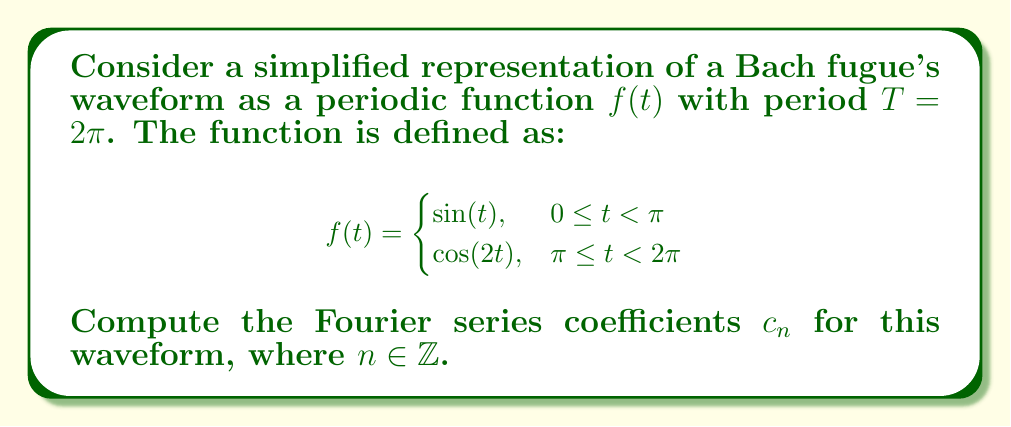Can you solve this math problem? To find the Fourier series coefficients $c_n$, we use the formula:

$$c_n = \frac{1}{T} \int_0^T f(t) e^{-i n t} dt$$

Where $T = 2\pi$ in this case. We split the integral into two parts:

$$c_n = \frac{1}{2\pi} \left( \int_0^\pi \sin(t) e^{-int} dt + \int_\pi^{2\pi} \cos(2t) e^{-int} dt \right)$$

For the first integral:
$$I_1 = \int_0^\pi \sin(t) e^{-int} dt = \frac{1}{1-n^2} \left( e^{-in\pi} + in - 1 \right)$$

For the second integral:
$$I_2 = \int_\pi^{2\pi} \cos(2t) e^{-int} dt = \frac{1}{4-n^2} \left( 2e^{-2in\pi} - 2e^{-in\pi} \right)$$

Combining these results:

$$c_n = \frac{1}{2\pi} \left( \frac{1}{1-n^2} \left( e^{-in\pi} + in - 1 \right) + \frac{1}{4-n^2} \left( 2e^{-2in\pi} - 2e^{-in\pi} \right) \right)$$

Simplifying and using Euler's formula $e^{-in\pi} = (-1)^n$:

$$c_n = \frac{1}{2\pi} \left( \frac{(-1)^n + in - 1}{1-n^2} + \frac{2(-1)^{2n} - 2(-1)^n}{4-n^2} \right)$$

This expression gives us the Fourier series coefficients for all integer values of $n$, including $n=0, \pm 1, \pm 2, ...$
Answer: The Fourier series coefficients for the given waveform are:

$$c_n = \frac{1}{2\pi} \left( \frac{(-1)^n + in - 1}{1-n^2} + \frac{2(-1)^{2n} - 2(-1)^n}{4-n^2} \right)$$

for all $n \in \mathbb{Z}$. 